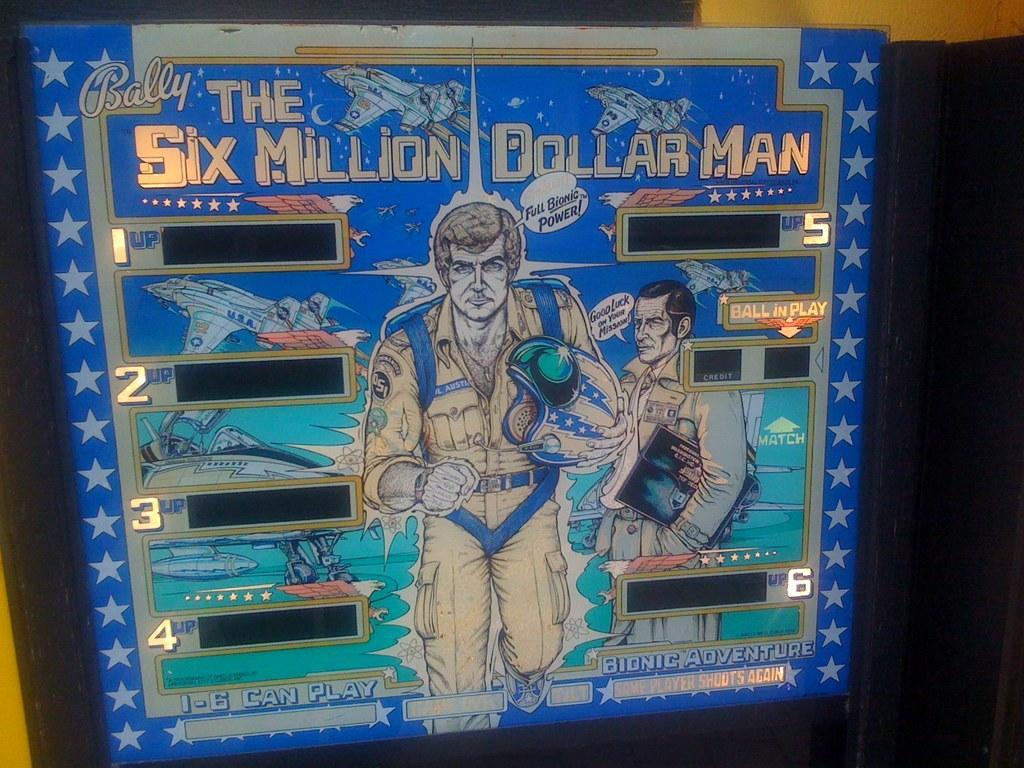Describe this image in one or two sentences. In this image I can see the animated image. 